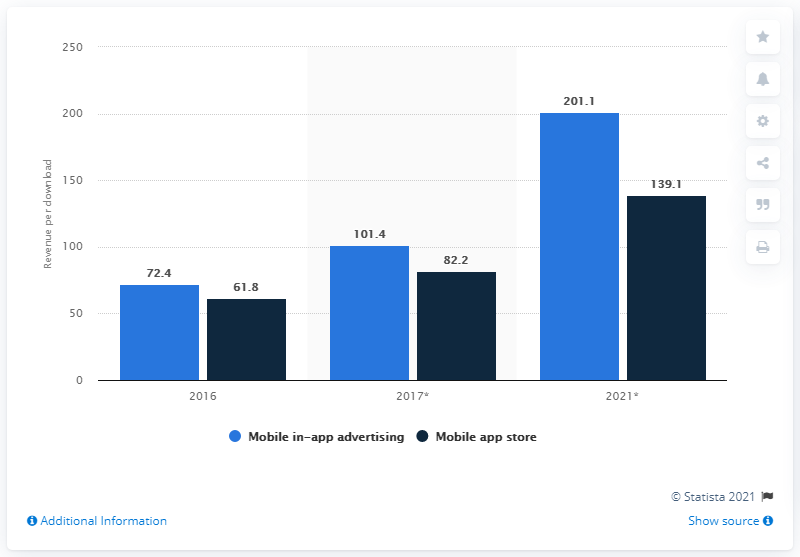Outline some significant characteristics in this image. In 2016, worldwide spending on in-app advertising and app stores was measured. In 2016, the total amount of money that advertisers spent on ads within mobile apps was approximately $72.4 billion. In 2021, it is projected that there will be a significant amount of gross advertiser spend within mobile apps, estimated to be approximately 201.1... 